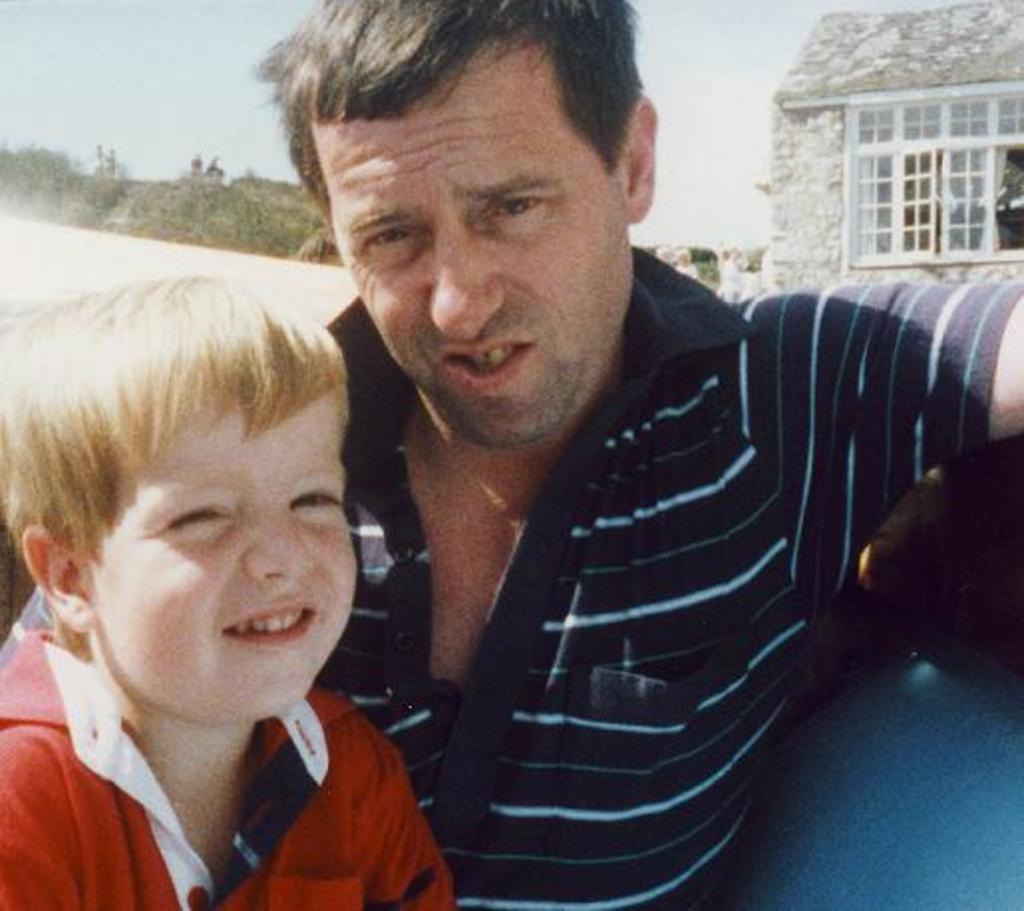What is happening in the image? There is a man sitting with a child in the image. What can be seen in the background of the image? There are trees, a house with windows, and the sky visible in the background of the image. How does the sky look in the image? The sky appears to be cloudy in the image. What type of gold object is being held by the dolls in the image? There are no dolls or gold objects present in the image. What shape is the square object being used by the child in the image? There is no square object present in the image. 